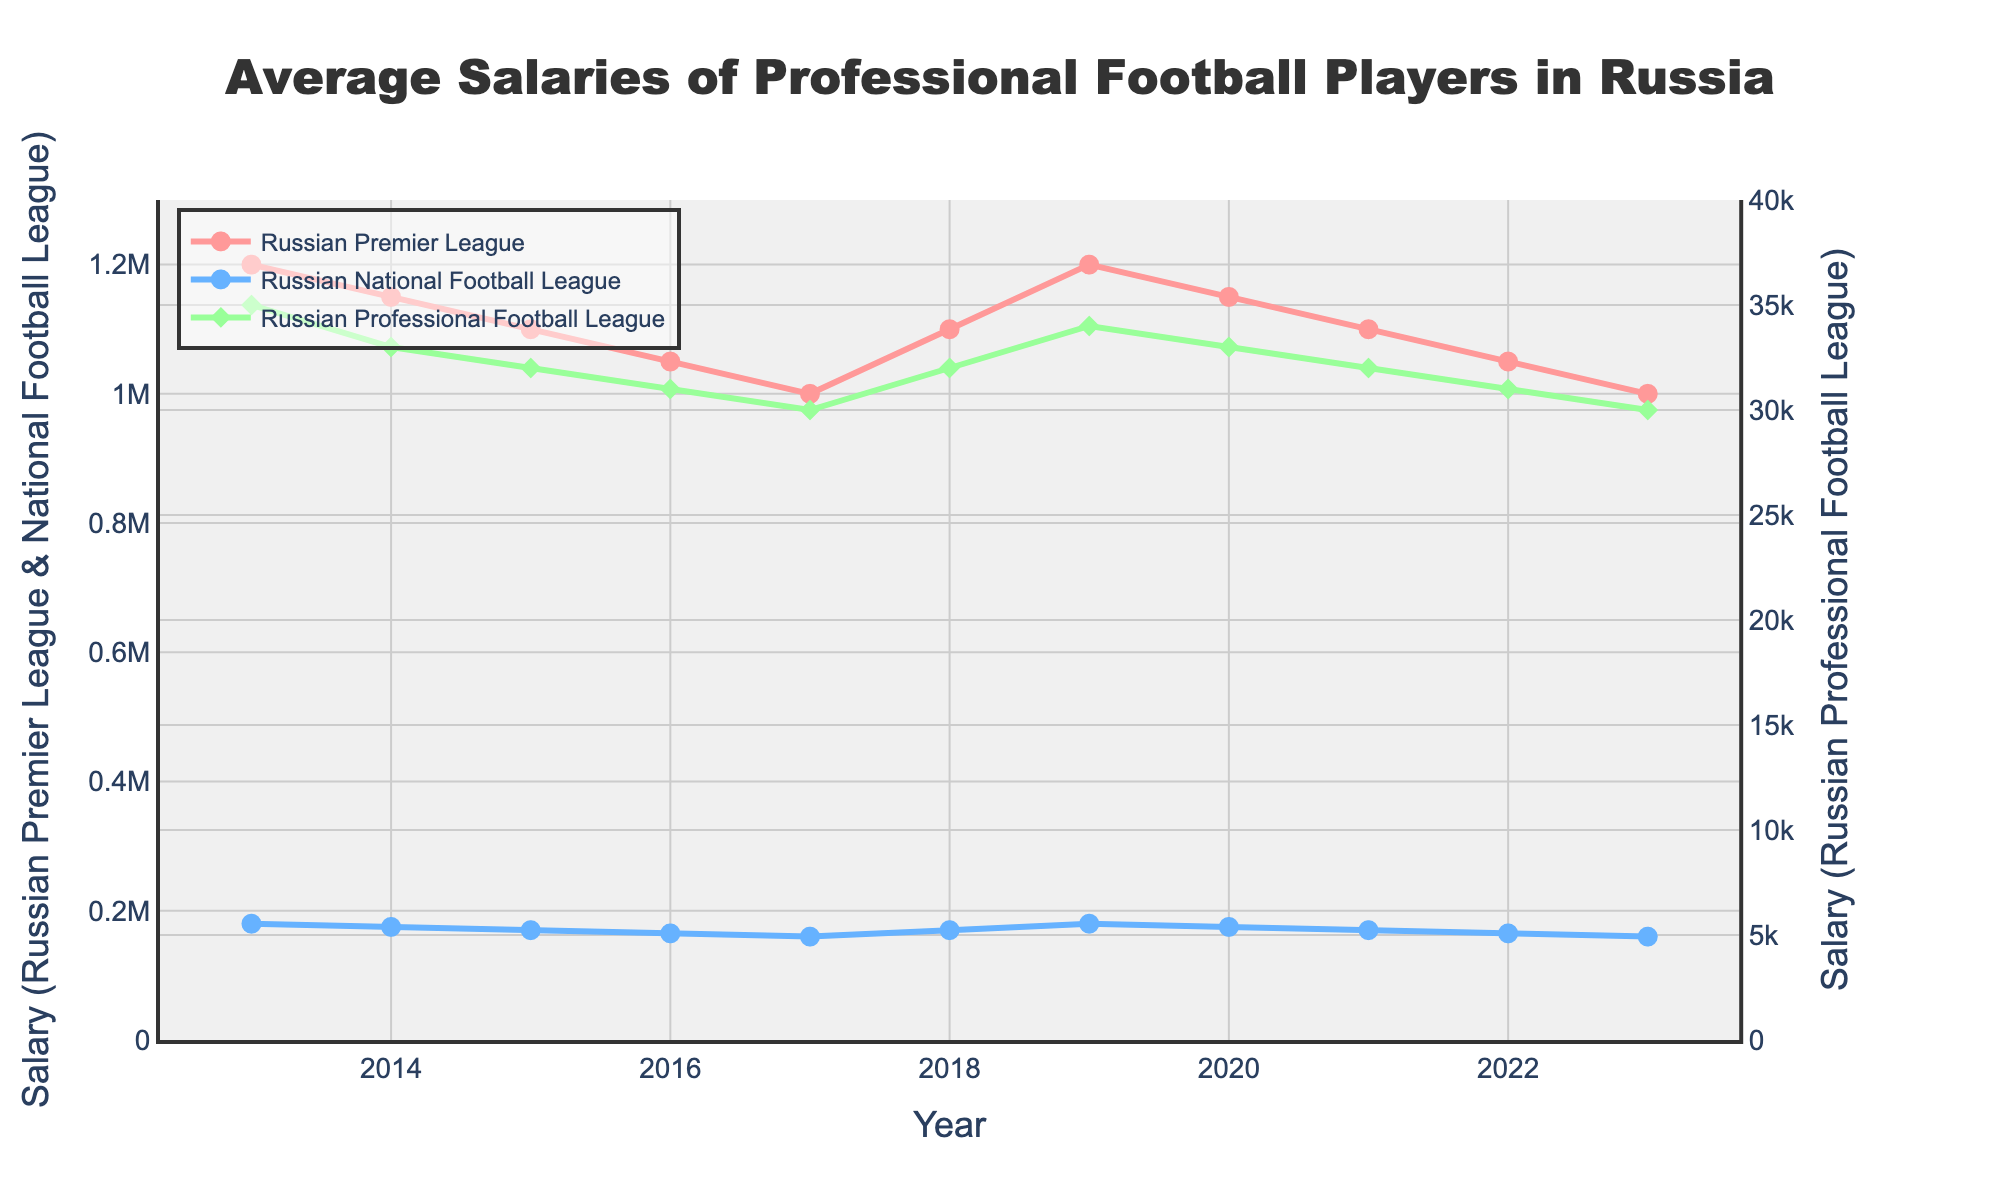Which league had the highest average salary in 2023? In 2023, the Russian Premier League had the highest average salary. The line representing this league is the topmost line on the chart, with its corresponding value the highest among the three leagues.
Answer: Russian Premier League How did the average salary in the Russian National Football League change from 2018 to 2019? In 2018, the average salary in the Russian National Football League was 170,000, and in 2019 it increased to 180,000. This change can be observed by comparing the values on the chart for these two years.
Answer: It increased by 10,000 What is the difference in average salary between the Russian Premier League and the Russian Professional Football League in 2020? In 2020, the Russian Premier League had an average salary of 1,150,000, and the Russian Professional Football League had an average salary of 33,000. The difference is calculated by subtracting the smaller salary from the larger one: 1,150,000 - 33,000 = 1,117,000.
Answer: 1,117,000 Which year saw the highest average salary for the Russian Premier League in this dataset? The highest average salary for the Russian Premier League in this dataset is observed in 2013, with a value of 1,200,000. This can be seen by identifying the highest point on the line representing the Russian Premier League.
Answer: 2013 Is the average salary trend for the Russian National Football League increasing or decreasing from 2013 to 2023? From 2013 to 2023, the average salary trend for the Russian National Football League is overall decreasing. This can be observed from the downward slope of the line representing the league over this period.
Answer: Decreasing Between which consecutive years did the Russian Premier League see the largest drop in average salary? The largest drop in average salary for the Russian Premier League occurred between 2013 and 2014, where the salary decreased from 1,200,000 to 1,150,000. This can be observed by the steepest downward segment on the chart for this league.
Answer: 2013 to 2014 What was the average salary in the Russian Professional Football League in 2021 compared to its salary in 2013? In 2021, the average salary in the Russian Professional Football League was 32,000, and in 2013 it was 35,000. The difference can be calculated and the comparison is presented directly by looking at the values on the chart.
Answer: It was lower in 2021 Compare the visual thickness and marker size between the Russian Premier League and the Russian Professional Football League. The Russian Premier League has thicker lines and larger marker sizes compared to the Russian Professional Football League. This is visible in their respective visual representation on the chart.
Answer: Russian Premier League has thicker lines and larger markers What is the average salary of the Russian Premier League over the decade? To find the average salary of the Russian Premier League over the decade, sum up the salaries for each year (1,200,000 + 1,150,000 + 1,100,000 + 1,050,000 + 1,000,000 + 1,100,000 + 1,200,000 + 1,150,000 + 1,100,000 + 1,050,000 + 1,000,000) and divide by the number of years (11). This calculates to (12,100,000 / 11).
Answer: 1,100,000 